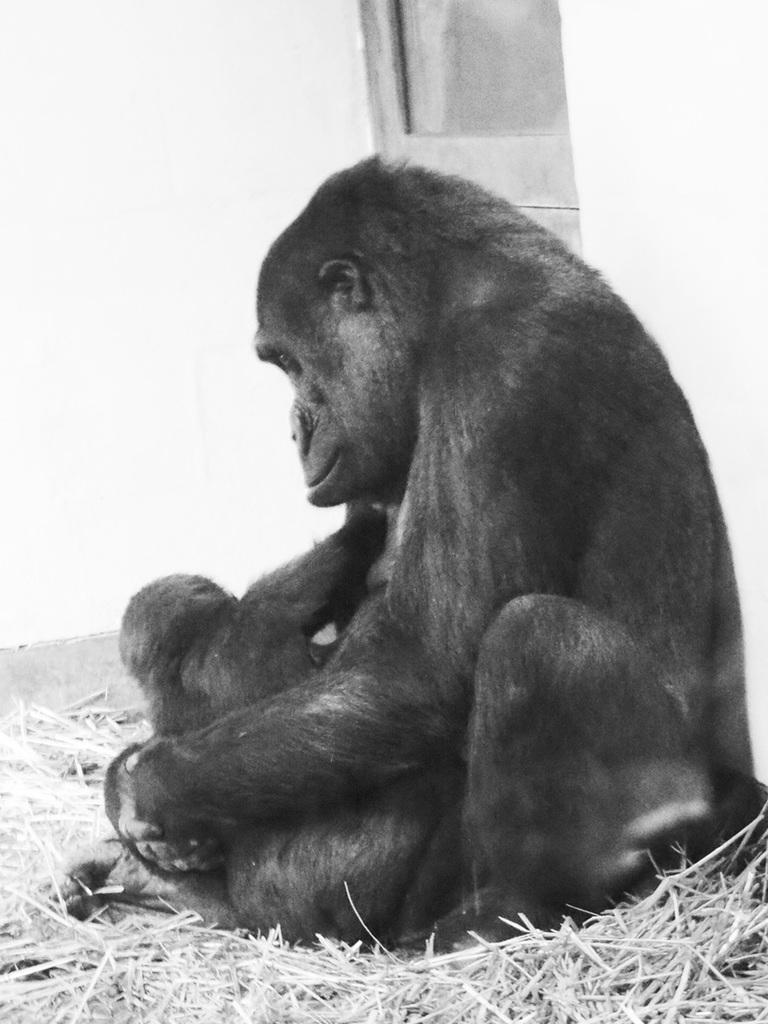What type of animal is in the image? There is a gorilla in the image. Can you describe the gorilla in the image? There is an infant gorilla in the image. What type of vegetation is present in the image? Dried grass is present in the image. What is the background of the image? There is a wall in the image. What type of bell can be heard ringing in the image? There is no bell present in the image, and therefore no sound can be heard. 